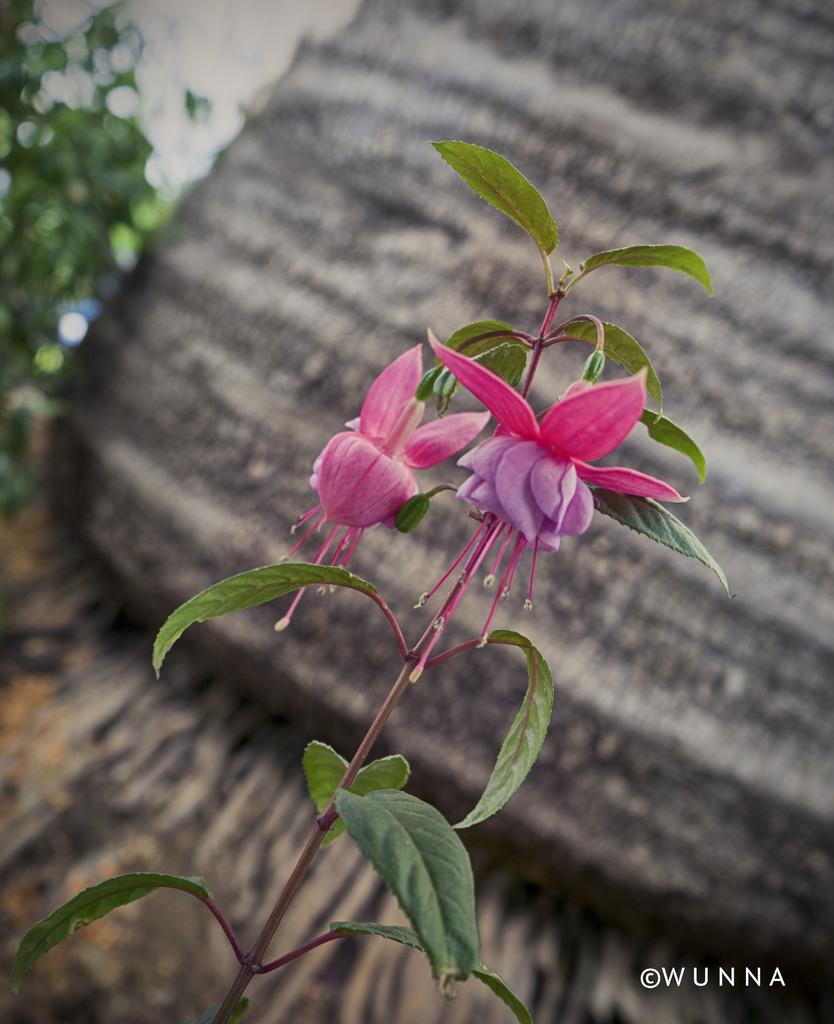What type of plant is featured in the image? The image contains flowers of a plant. What part of a tree can be seen in the background of the image? The bark of a tree is visible in the background of the image. What else is present in the image besides the flowers? There are plants in the image. Where is the text located in the image? The text is in the bottom right corner of the image. What type of pleasure can be seen enjoying the flowers in the image? There is no indication of pleasure or any living being enjoying the flowers in the image. 